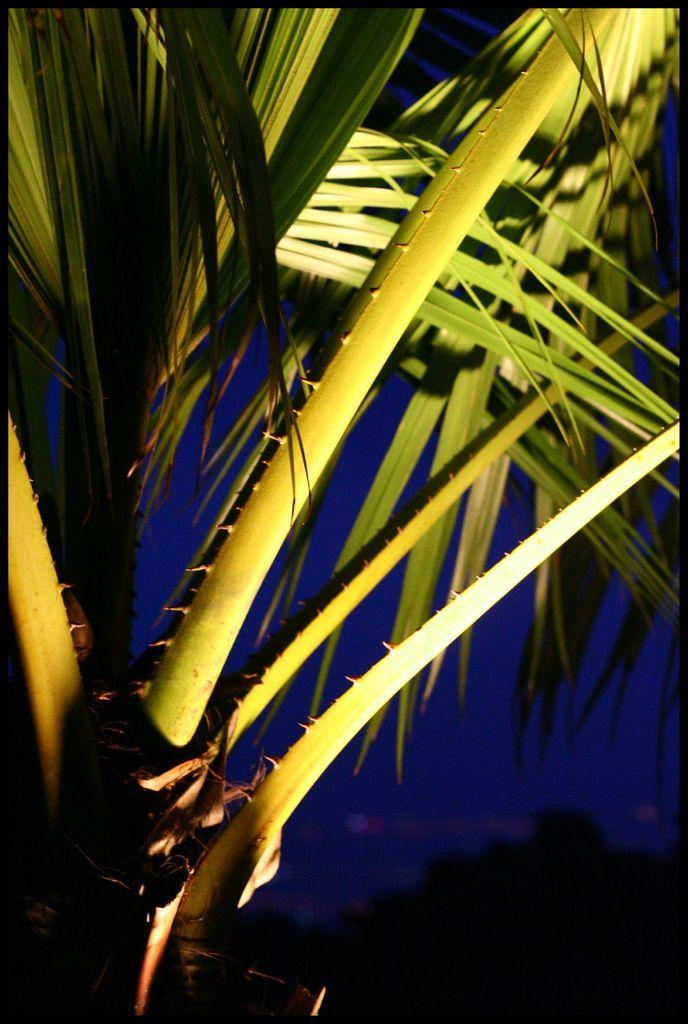What type of tree is in the image? There is a coconut tree in the image. What part of the tree is visible in the image? The image shows the upper part of the tree. What can be seen on the branches of the tree? The tree has branches with leaves. How many robins are sitting on the branches of the tree in the image? There are no robins present in the image; it only shows the upper part of the coconut tree with branches and leaves. 